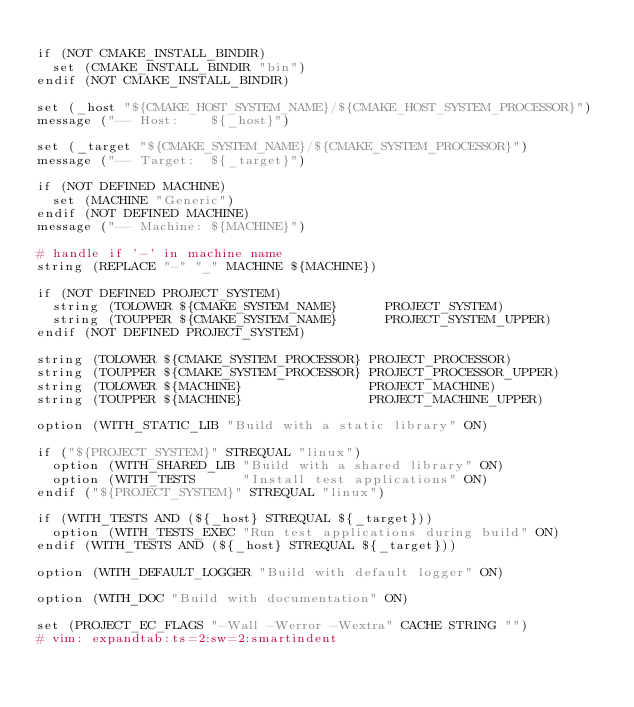<code> <loc_0><loc_0><loc_500><loc_500><_CMake_>
if (NOT CMAKE_INSTALL_BINDIR)
  set (CMAKE_INSTALL_BINDIR "bin")
endif (NOT CMAKE_INSTALL_BINDIR)

set (_host "${CMAKE_HOST_SYSTEM_NAME}/${CMAKE_HOST_SYSTEM_PROCESSOR}")
message ("-- Host:    ${_host}")

set (_target "${CMAKE_SYSTEM_NAME}/${CMAKE_SYSTEM_PROCESSOR}")
message ("-- Target:  ${_target}")

if (NOT DEFINED MACHINE)
  set (MACHINE "Generic")
endif (NOT DEFINED MACHINE)
message ("-- Machine: ${MACHINE}")

# handle if '-' in machine name
string (REPLACE "-" "_" MACHINE ${MACHINE})

if (NOT DEFINED PROJECT_SYSTEM)
  string (TOLOWER ${CMAKE_SYSTEM_NAME}      PROJECT_SYSTEM)
  string (TOUPPER ${CMAKE_SYSTEM_NAME}      PROJECT_SYSTEM_UPPER)
endif (NOT DEFINED PROJECT_SYSTEM)

string (TOLOWER ${CMAKE_SYSTEM_PROCESSOR} PROJECT_PROCESSOR)
string (TOUPPER ${CMAKE_SYSTEM_PROCESSOR} PROJECT_PROCESSOR_UPPER)
string (TOLOWER ${MACHINE}                PROJECT_MACHINE)
string (TOUPPER ${MACHINE}                PROJECT_MACHINE_UPPER)

option (WITH_STATIC_LIB "Build with a static library" ON)

if ("${PROJECT_SYSTEM}" STREQUAL "linux")
  option (WITH_SHARED_LIB "Build with a shared library" ON)
  option (WITH_TESTS      "Install test applications" ON)
endif ("${PROJECT_SYSTEM}" STREQUAL "linux")

if (WITH_TESTS AND (${_host} STREQUAL ${_target}))
  option (WITH_TESTS_EXEC "Run test applications during build" ON)
endif (WITH_TESTS AND (${_host} STREQUAL ${_target}))

option (WITH_DEFAULT_LOGGER "Build with default logger" ON)

option (WITH_DOC "Build with documentation" ON)

set (PROJECT_EC_FLAGS "-Wall -Werror -Wextra" CACHE STRING "")
# vim: expandtab:ts=2:sw=2:smartindent
</code> 